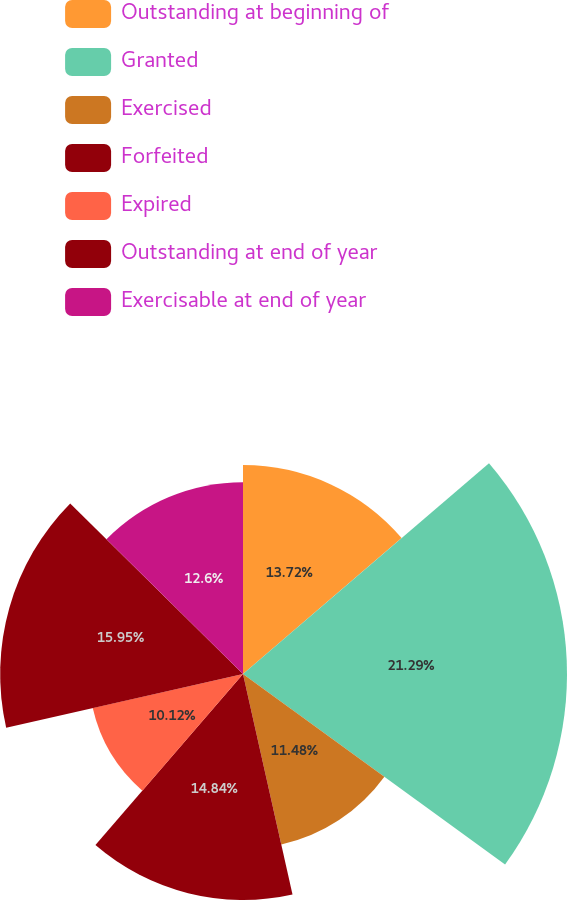<chart> <loc_0><loc_0><loc_500><loc_500><pie_chart><fcel>Outstanding at beginning of<fcel>Granted<fcel>Exercised<fcel>Forfeited<fcel>Expired<fcel>Outstanding at end of year<fcel>Exercisable at end of year<nl><fcel>13.72%<fcel>21.28%<fcel>11.48%<fcel>14.84%<fcel>10.12%<fcel>15.95%<fcel>12.6%<nl></chart> 